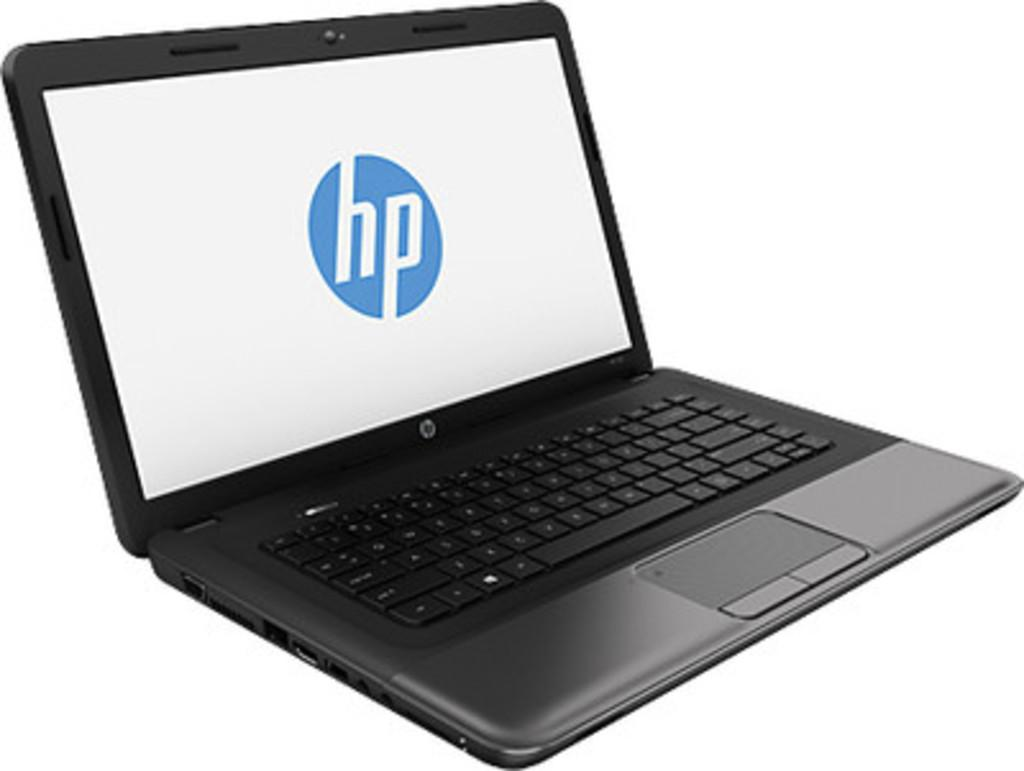Provide a one-sentence caption for the provided image. A laptop that has the HP logo on the screen. 